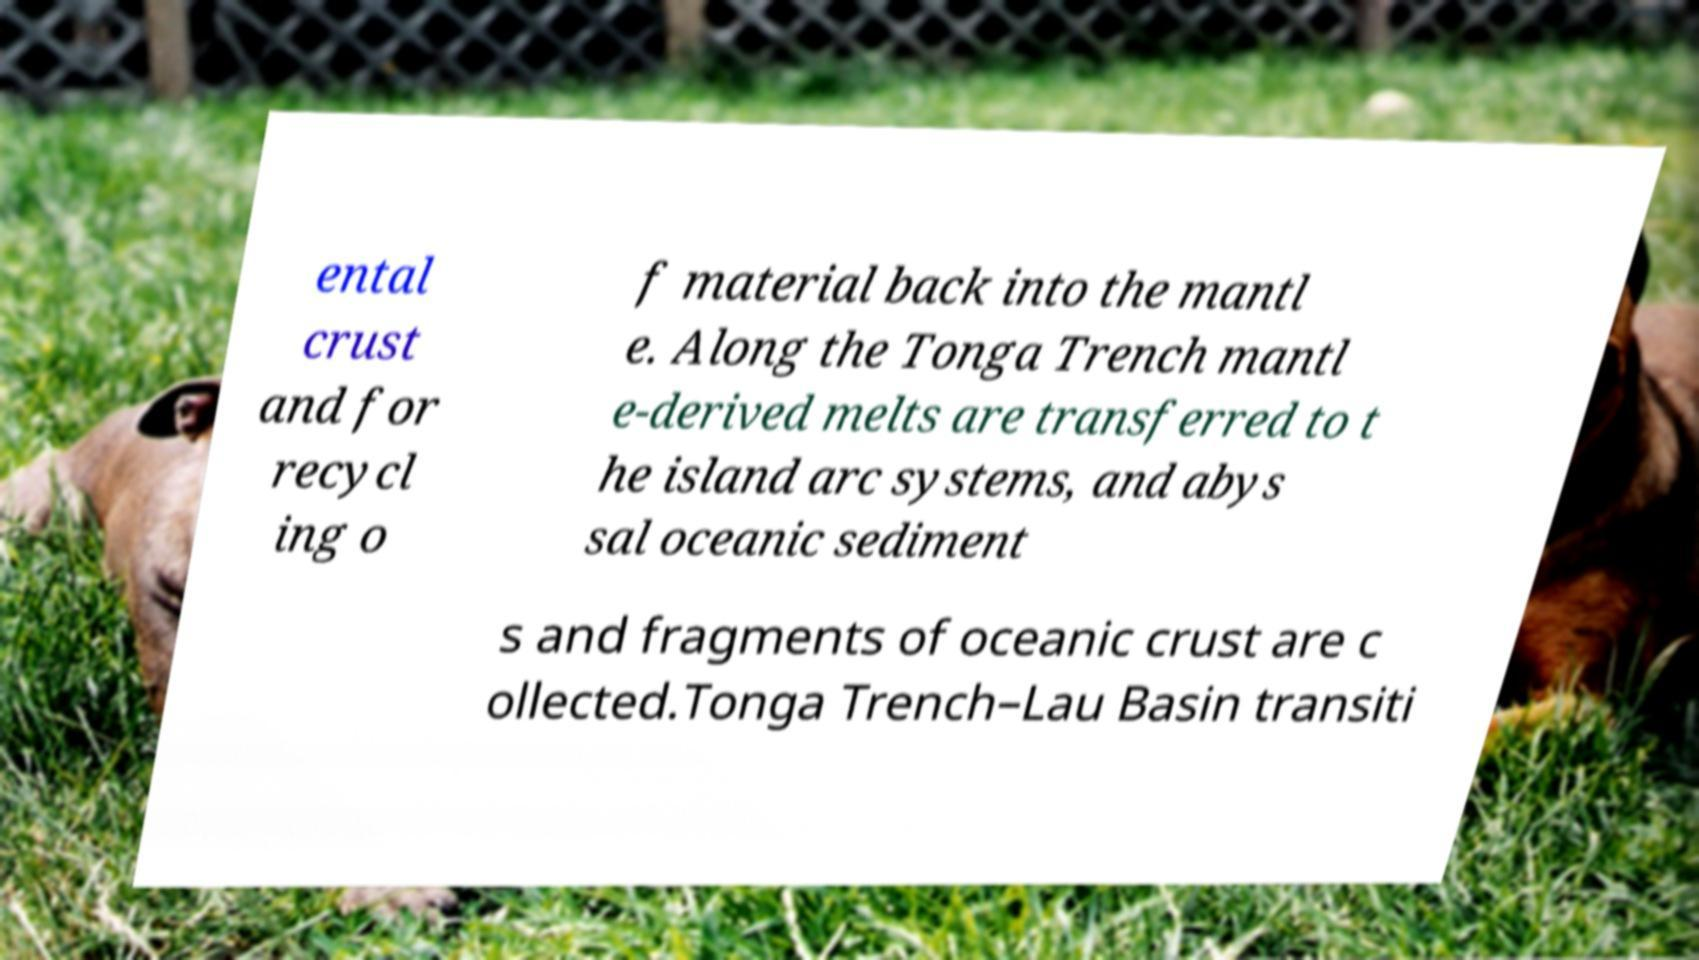For documentation purposes, I need the text within this image transcribed. Could you provide that? ental crust and for recycl ing o f material back into the mantl e. Along the Tonga Trench mantl e-derived melts are transferred to t he island arc systems, and abys sal oceanic sediment s and fragments of oceanic crust are c ollected.Tonga Trench–Lau Basin transiti 